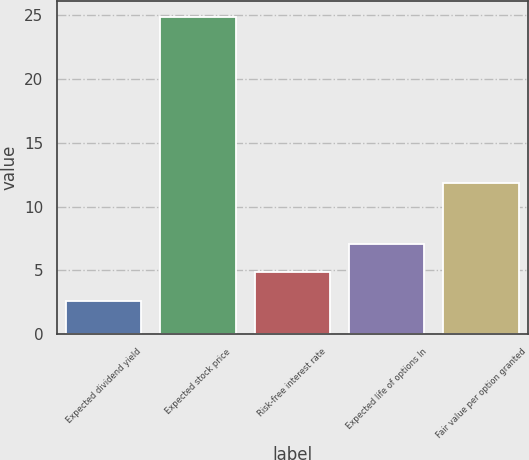Convert chart. <chart><loc_0><loc_0><loc_500><loc_500><bar_chart><fcel>Expected dividend yield<fcel>Expected stock price<fcel>Risk-free interest rate<fcel>Expected life of options In<fcel>Fair value per option granted<nl><fcel>2.6<fcel>24.9<fcel>4.83<fcel>7.06<fcel>11.85<nl></chart> 